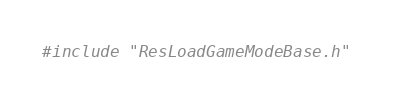<code> <loc_0><loc_0><loc_500><loc_500><_C++_>

#include "ResLoadGameModeBase.h"

</code> 